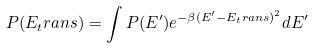<formula> <loc_0><loc_0><loc_500><loc_500>P ( E _ { t } r a n s ) = \int { P ( E ^ { \prime } ) e ^ { - \beta ( E ^ { \prime } - E _ { t } r a n s ) ^ { 2 } } d E ^ { \prime } }</formula> 